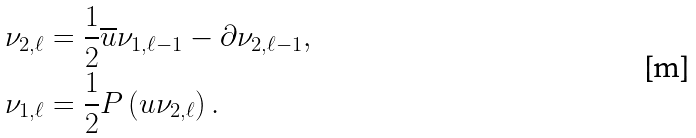Convert formula to latex. <formula><loc_0><loc_0><loc_500><loc_500>\nu _ { 2 , \ell } & = \frac { 1 } { 2 } \overline { u } \nu _ { 1 , \ell - 1 } - \partial \nu _ { 2 , \ell - 1 } , \\ \nu _ { 1 , \ell } & = \frac { 1 } { 2 } P \left ( u \nu _ { 2 , \ell } \right ) .</formula> 